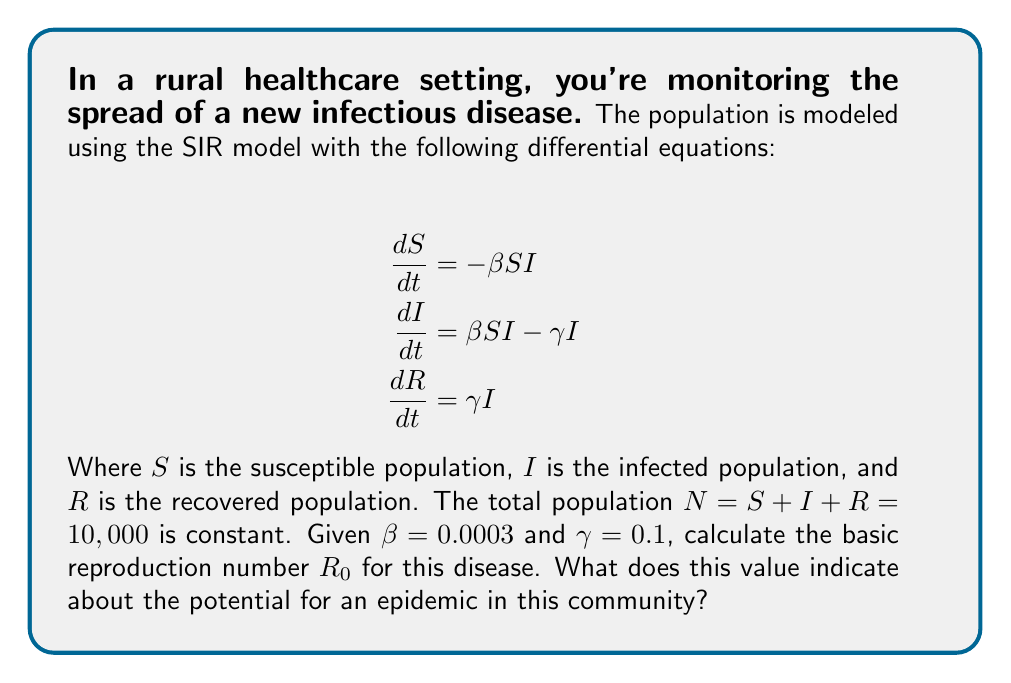Can you solve this math problem? To solve this problem, we'll follow these steps:

1) The basic reproduction number $R_0$ is defined as the average number of secondary infections caused by one infected individual in a completely susceptible population.

2) For the SIR model, $R_0$ is given by the formula:

   $$R_0 = \frac{\beta N}{\gamma}$$

   Where:
   - $\beta$ is the infection rate
   - $N$ is the total population
   - $\gamma$ is the recovery rate

3) We're given:
   - $\beta = 0.0003$
   - $\gamma = 0.1$
   - $N = 10,000$

4) Let's substitute these values into the formula:

   $$R_0 = \frac{0.0003 \times 10,000}{0.1}$$

5) Simplify:
   
   $$R_0 = \frac{3}{0.1} = 30$$

6) Interpretation: 
   - If $R_0 > 1$, the disease will spread and there's potential for an epidemic.
   - If $R_0 < 1$, the disease will die out.

   Here, $R_0 = 30$, which is significantly greater than 1. This indicates a high potential for an epidemic in this community. Each infected person is expected to infect 30 others in a completely susceptible population.
Answer: $R_0 = 30$; high epidemic potential 